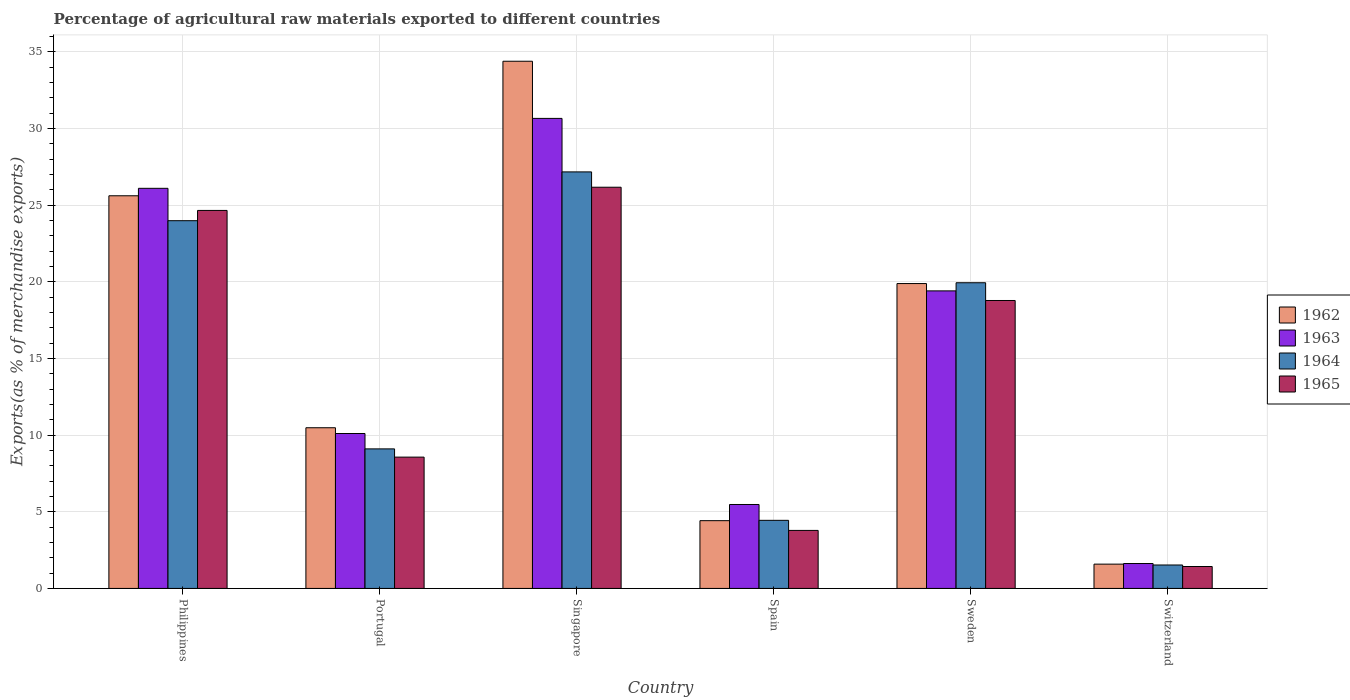Are the number of bars on each tick of the X-axis equal?
Your response must be concise. Yes. How many bars are there on the 6th tick from the left?
Your answer should be compact. 4. How many bars are there on the 4th tick from the right?
Offer a terse response. 4. What is the percentage of exports to different countries in 1964 in Spain?
Provide a short and direct response. 4.44. Across all countries, what is the maximum percentage of exports to different countries in 1962?
Give a very brief answer. 34.38. Across all countries, what is the minimum percentage of exports to different countries in 1965?
Give a very brief answer. 1.43. In which country was the percentage of exports to different countries in 1962 maximum?
Provide a succinct answer. Singapore. In which country was the percentage of exports to different countries in 1965 minimum?
Provide a succinct answer. Switzerland. What is the total percentage of exports to different countries in 1963 in the graph?
Offer a very short reply. 93.34. What is the difference between the percentage of exports to different countries in 1965 in Philippines and that in Portugal?
Your answer should be compact. 16.08. What is the difference between the percentage of exports to different countries in 1965 in Singapore and the percentage of exports to different countries in 1963 in Philippines?
Keep it short and to the point. 0.07. What is the average percentage of exports to different countries in 1964 per country?
Offer a very short reply. 14.36. What is the difference between the percentage of exports to different countries of/in 1965 and percentage of exports to different countries of/in 1964 in Portugal?
Give a very brief answer. -0.54. In how many countries, is the percentage of exports to different countries in 1964 greater than 20 %?
Provide a succinct answer. 2. What is the ratio of the percentage of exports to different countries in 1963 in Philippines to that in Sweden?
Your answer should be very brief. 1.34. What is the difference between the highest and the second highest percentage of exports to different countries in 1962?
Your response must be concise. -8.77. What is the difference between the highest and the lowest percentage of exports to different countries in 1963?
Ensure brevity in your answer.  29.02. What does the 4th bar from the left in Sweden represents?
Your answer should be compact. 1965. What does the 2nd bar from the right in Singapore represents?
Your answer should be very brief. 1964. How many countries are there in the graph?
Your response must be concise. 6. What is the difference between two consecutive major ticks on the Y-axis?
Offer a very short reply. 5. Does the graph contain any zero values?
Your answer should be compact. No. Where does the legend appear in the graph?
Your response must be concise. Center right. How many legend labels are there?
Provide a succinct answer. 4. How are the legend labels stacked?
Offer a terse response. Vertical. What is the title of the graph?
Your answer should be compact. Percentage of agricultural raw materials exported to different countries. What is the label or title of the X-axis?
Your answer should be compact. Country. What is the label or title of the Y-axis?
Ensure brevity in your answer.  Exports(as % of merchandise exports). What is the Exports(as % of merchandise exports) of 1962 in Philippines?
Your answer should be compact. 25.6. What is the Exports(as % of merchandise exports) of 1963 in Philippines?
Provide a succinct answer. 26.09. What is the Exports(as % of merchandise exports) of 1964 in Philippines?
Ensure brevity in your answer.  23.98. What is the Exports(as % of merchandise exports) in 1965 in Philippines?
Give a very brief answer. 24.65. What is the Exports(as % of merchandise exports) of 1962 in Portugal?
Your answer should be compact. 10.48. What is the Exports(as % of merchandise exports) in 1963 in Portugal?
Give a very brief answer. 10.1. What is the Exports(as % of merchandise exports) in 1964 in Portugal?
Offer a very short reply. 9.1. What is the Exports(as % of merchandise exports) in 1965 in Portugal?
Ensure brevity in your answer.  8.56. What is the Exports(as % of merchandise exports) in 1962 in Singapore?
Your response must be concise. 34.38. What is the Exports(as % of merchandise exports) of 1963 in Singapore?
Ensure brevity in your answer.  30.65. What is the Exports(as % of merchandise exports) in 1964 in Singapore?
Make the answer very short. 27.16. What is the Exports(as % of merchandise exports) of 1965 in Singapore?
Your response must be concise. 26.16. What is the Exports(as % of merchandise exports) of 1962 in Spain?
Make the answer very short. 4.42. What is the Exports(as % of merchandise exports) in 1963 in Spain?
Make the answer very short. 5.47. What is the Exports(as % of merchandise exports) of 1964 in Spain?
Your answer should be very brief. 4.44. What is the Exports(as % of merchandise exports) of 1965 in Spain?
Your answer should be compact. 3.78. What is the Exports(as % of merchandise exports) in 1962 in Sweden?
Give a very brief answer. 19.88. What is the Exports(as % of merchandise exports) in 1963 in Sweden?
Ensure brevity in your answer.  19.4. What is the Exports(as % of merchandise exports) in 1964 in Sweden?
Your response must be concise. 19.93. What is the Exports(as % of merchandise exports) of 1965 in Sweden?
Ensure brevity in your answer.  18.78. What is the Exports(as % of merchandise exports) of 1962 in Switzerland?
Offer a terse response. 1.58. What is the Exports(as % of merchandise exports) in 1963 in Switzerland?
Your answer should be very brief. 1.62. What is the Exports(as % of merchandise exports) in 1964 in Switzerland?
Ensure brevity in your answer.  1.53. What is the Exports(as % of merchandise exports) of 1965 in Switzerland?
Make the answer very short. 1.43. Across all countries, what is the maximum Exports(as % of merchandise exports) in 1962?
Give a very brief answer. 34.38. Across all countries, what is the maximum Exports(as % of merchandise exports) of 1963?
Your answer should be compact. 30.65. Across all countries, what is the maximum Exports(as % of merchandise exports) in 1964?
Offer a very short reply. 27.16. Across all countries, what is the maximum Exports(as % of merchandise exports) of 1965?
Your response must be concise. 26.16. Across all countries, what is the minimum Exports(as % of merchandise exports) in 1962?
Keep it short and to the point. 1.58. Across all countries, what is the minimum Exports(as % of merchandise exports) of 1963?
Give a very brief answer. 1.62. Across all countries, what is the minimum Exports(as % of merchandise exports) in 1964?
Ensure brevity in your answer.  1.53. Across all countries, what is the minimum Exports(as % of merchandise exports) in 1965?
Make the answer very short. 1.43. What is the total Exports(as % of merchandise exports) in 1962 in the graph?
Keep it short and to the point. 96.34. What is the total Exports(as % of merchandise exports) of 1963 in the graph?
Keep it short and to the point. 93.34. What is the total Exports(as % of merchandise exports) of 1964 in the graph?
Your answer should be compact. 86.14. What is the total Exports(as % of merchandise exports) of 1965 in the graph?
Keep it short and to the point. 83.36. What is the difference between the Exports(as % of merchandise exports) in 1962 in Philippines and that in Portugal?
Provide a succinct answer. 15.13. What is the difference between the Exports(as % of merchandise exports) of 1963 in Philippines and that in Portugal?
Your answer should be very brief. 15.99. What is the difference between the Exports(as % of merchandise exports) of 1964 in Philippines and that in Portugal?
Provide a succinct answer. 14.88. What is the difference between the Exports(as % of merchandise exports) of 1965 in Philippines and that in Portugal?
Offer a very short reply. 16.08. What is the difference between the Exports(as % of merchandise exports) in 1962 in Philippines and that in Singapore?
Keep it short and to the point. -8.77. What is the difference between the Exports(as % of merchandise exports) in 1963 in Philippines and that in Singapore?
Your response must be concise. -4.56. What is the difference between the Exports(as % of merchandise exports) of 1964 in Philippines and that in Singapore?
Ensure brevity in your answer.  -3.18. What is the difference between the Exports(as % of merchandise exports) of 1965 in Philippines and that in Singapore?
Your answer should be compact. -1.51. What is the difference between the Exports(as % of merchandise exports) of 1962 in Philippines and that in Spain?
Provide a succinct answer. 21.19. What is the difference between the Exports(as % of merchandise exports) in 1963 in Philippines and that in Spain?
Ensure brevity in your answer.  20.62. What is the difference between the Exports(as % of merchandise exports) in 1964 in Philippines and that in Spain?
Keep it short and to the point. 19.54. What is the difference between the Exports(as % of merchandise exports) of 1965 in Philippines and that in Spain?
Provide a succinct answer. 20.86. What is the difference between the Exports(as % of merchandise exports) in 1962 in Philippines and that in Sweden?
Keep it short and to the point. 5.72. What is the difference between the Exports(as % of merchandise exports) of 1963 in Philippines and that in Sweden?
Make the answer very short. 6.69. What is the difference between the Exports(as % of merchandise exports) in 1964 in Philippines and that in Sweden?
Offer a terse response. 4.05. What is the difference between the Exports(as % of merchandise exports) in 1965 in Philippines and that in Sweden?
Keep it short and to the point. 5.87. What is the difference between the Exports(as % of merchandise exports) of 1962 in Philippines and that in Switzerland?
Ensure brevity in your answer.  24.02. What is the difference between the Exports(as % of merchandise exports) of 1963 in Philippines and that in Switzerland?
Ensure brevity in your answer.  24.47. What is the difference between the Exports(as % of merchandise exports) of 1964 in Philippines and that in Switzerland?
Your response must be concise. 22.45. What is the difference between the Exports(as % of merchandise exports) of 1965 in Philippines and that in Switzerland?
Offer a very short reply. 23.22. What is the difference between the Exports(as % of merchandise exports) of 1962 in Portugal and that in Singapore?
Make the answer very short. -23.9. What is the difference between the Exports(as % of merchandise exports) in 1963 in Portugal and that in Singapore?
Keep it short and to the point. -20.55. What is the difference between the Exports(as % of merchandise exports) in 1964 in Portugal and that in Singapore?
Make the answer very short. -18.06. What is the difference between the Exports(as % of merchandise exports) in 1965 in Portugal and that in Singapore?
Offer a very short reply. -17.6. What is the difference between the Exports(as % of merchandise exports) in 1962 in Portugal and that in Spain?
Give a very brief answer. 6.06. What is the difference between the Exports(as % of merchandise exports) of 1963 in Portugal and that in Spain?
Your answer should be compact. 4.63. What is the difference between the Exports(as % of merchandise exports) of 1964 in Portugal and that in Spain?
Offer a very short reply. 4.66. What is the difference between the Exports(as % of merchandise exports) in 1965 in Portugal and that in Spain?
Ensure brevity in your answer.  4.78. What is the difference between the Exports(as % of merchandise exports) in 1962 in Portugal and that in Sweden?
Your answer should be very brief. -9.4. What is the difference between the Exports(as % of merchandise exports) in 1963 in Portugal and that in Sweden?
Your answer should be compact. -9.3. What is the difference between the Exports(as % of merchandise exports) of 1964 in Portugal and that in Sweden?
Offer a terse response. -10.83. What is the difference between the Exports(as % of merchandise exports) of 1965 in Portugal and that in Sweden?
Give a very brief answer. -10.21. What is the difference between the Exports(as % of merchandise exports) in 1962 in Portugal and that in Switzerland?
Keep it short and to the point. 8.89. What is the difference between the Exports(as % of merchandise exports) in 1963 in Portugal and that in Switzerland?
Offer a very short reply. 8.48. What is the difference between the Exports(as % of merchandise exports) of 1964 in Portugal and that in Switzerland?
Provide a succinct answer. 7.57. What is the difference between the Exports(as % of merchandise exports) in 1965 in Portugal and that in Switzerland?
Ensure brevity in your answer.  7.13. What is the difference between the Exports(as % of merchandise exports) of 1962 in Singapore and that in Spain?
Keep it short and to the point. 29.96. What is the difference between the Exports(as % of merchandise exports) of 1963 in Singapore and that in Spain?
Your answer should be very brief. 25.18. What is the difference between the Exports(as % of merchandise exports) in 1964 in Singapore and that in Spain?
Keep it short and to the point. 22.72. What is the difference between the Exports(as % of merchandise exports) in 1965 in Singapore and that in Spain?
Give a very brief answer. 22.38. What is the difference between the Exports(as % of merchandise exports) in 1962 in Singapore and that in Sweden?
Your response must be concise. 14.5. What is the difference between the Exports(as % of merchandise exports) in 1963 in Singapore and that in Sweden?
Provide a succinct answer. 11.25. What is the difference between the Exports(as % of merchandise exports) of 1964 in Singapore and that in Sweden?
Your answer should be very brief. 7.23. What is the difference between the Exports(as % of merchandise exports) of 1965 in Singapore and that in Sweden?
Your answer should be compact. 7.39. What is the difference between the Exports(as % of merchandise exports) in 1962 in Singapore and that in Switzerland?
Offer a very short reply. 32.79. What is the difference between the Exports(as % of merchandise exports) of 1963 in Singapore and that in Switzerland?
Your response must be concise. 29.02. What is the difference between the Exports(as % of merchandise exports) in 1964 in Singapore and that in Switzerland?
Your answer should be compact. 25.63. What is the difference between the Exports(as % of merchandise exports) of 1965 in Singapore and that in Switzerland?
Provide a succinct answer. 24.73. What is the difference between the Exports(as % of merchandise exports) in 1962 in Spain and that in Sweden?
Offer a terse response. -15.46. What is the difference between the Exports(as % of merchandise exports) in 1963 in Spain and that in Sweden?
Your answer should be very brief. -13.93. What is the difference between the Exports(as % of merchandise exports) of 1964 in Spain and that in Sweden?
Your answer should be compact. -15.49. What is the difference between the Exports(as % of merchandise exports) in 1965 in Spain and that in Sweden?
Offer a very short reply. -14.99. What is the difference between the Exports(as % of merchandise exports) in 1962 in Spain and that in Switzerland?
Give a very brief answer. 2.83. What is the difference between the Exports(as % of merchandise exports) of 1963 in Spain and that in Switzerland?
Ensure brevity in your answer.  3.85. What is the difference between the Exports(as % of merchandise exports) in 1964 in Spain and that in Switzerland?
Your answer should be very brief. 2.91. What is the difference between the Exports(as % of merchandise exports) of 1965 in Spain and that in Switzerland?
Provide a short and direct response. 2.35. What is the difference between the Exports(as % of merchandise exports) of 1962 in Sweden and that in Switzerland?
Your answer should be very brief. 18.3. What is the difference between the Exports(as % of merchandise exports) in 1963 in Sweden and that in Switzerland?
Make the answer very short. 17.78. What is the difference between the Exports(as % of merchandise exports) of 1964 in Sweden and that in Switzerland?
Your answer should be compact. 18.4. What is the difference between the Exports(as % of merchandise exports) of 1965 in Sweden and that in Switzerland?
Your answer should be compact. 17.35. What is the difference between the Exports(as % of merchandise exports) in 1962 in Philippines and the Exports(as % of merchandise exports) in 1963 in Portugal?
Your answer should be very brief. 15.5. What is the difference between the Exports(as % of merchandise exports) of 1962 in Philippines and the Exports(as % of merchandise exports) of 1964 in Portugal?
Make the answer very short. 16.5. What is the difference between the Exports(as % of merchandise exports) in 1962 in Philippines and the Exports(as % of merchandise exports) in 1965 in Portugal?
Provide a short and direct response. 17.04. What is the difference between the Exports(as % of merchandise exports) of 1963 in Philippines and the Exports(as % of merchandise exports) of 1964 in Portugal?
Your response must be concise. 16.99. What is the difference between the Exports(as % of merchandise exports) of 1963 in Philippines and the Exports(as % of merchandise exports) of 1965 in Portugal?
Provide a succinct answer. 17.53. What is the difference between the Exports(as % of merchandise exports) of 1964 in Philippines and the Exports(as % of merchandise exports) of 1965 in Portugal?
Your answer should be very brief. 15.42. What is the difference between the Exports(as % of merchandise exports) in 1962 in Philippines and the Exports(as % of merchandise exports) in 1963 in Singapore?
Your answer should be compact. -5.04. What is the difference between the Exports(as % of merchandise exports) in 1962 in Philippines and the Exports(as % of merchandise exports) in 1964 in Singapore?
Provide a succinct answer. -1.56. What is the difference between the Exports(as % of merchandise exports) in 1962 in Philippines and the Exports(as % of merchandise exports) in 1965 in Singapore?
Your answer should be very brief. -0.56. What is the difference between the Exports(as % of merchandise exports) in 1963 in Philippines and the Exports(as % of merchandise exports) in 1964 in Singapore?
Ensure brevity in your answer.  -1.07. What is the difference between the Exports(as % of merchandise exports) in 1963 in Philippines and the Exports(as % of merchandise exports) in 1965 in Singapore?
Offer a terse response. -0.07. What is the difference between the Exports(as % of merchandise exports) in 1964 in Philippines and the Exports(as % of merchandise exports) in 1965 in Singapore?
Your answer should be compact. -2.18. What is the difference between the Exports(as % of merchandise exports) in 1962 in Philippines and the Exports(as % of merchandise exports) in 1963 in Spain?
Provide a succinct answer. 20.13. What is the difference between the Exports(as % of merchandise exports) of 1962 in Philippines and the Exports(as % of merchandise exports) of 1964 in Spain?
Provide a short and direct response. 21.16. What is the difference between the Exports(as % of merchandise exports) of 1962 in Philippines and the Exports(as % of merchandise exports) of 1965 in Spain?
Keep it short and to the point. 21.82. What is the difference between the Exports(as % of merchandise exports) in 1963 in Philippines and the Exports(as % of merchandise exports) in 1964 in Spain?
Your response must be concise. 21.65. What is the difference between the Exports(as % of merchandise exports) of 1963 in Philippines and the Exports(as % of merchandise exports) of 1965 in Spain?
Offer a very short reply. 22.31. What is the difference between the Exports(as % of merchandise exports) of 1964 in Philippines and the Exports(as % of merchandise exports) of 1965 in Spain?
Provide a succinct answer. 20.2. What is the difference between the Exports(as % of merchandise exports) of 1962 in Philippines and the Exports(as % of merchandise exports) of 1963 in Sweden?
Offer a very short reply. 6.2. What is the difference between the Exports(as % of merchandise exports) in 1962 in Philippines and the Exports(as % of merchandise exports) in 1964 in Sweden?
Make the answer very short. 5.67. What is the difference between the Exports(as % of merchandise exports) of 1962 in Philippines and the Exports(as % of merchandise exports) of 1965 in Sweden?
Your answer should be compact. 6.83. What is the difference between the Exports(as % of merchandise exports) in 1963 in Philippines and the Exports(as % of merchandise exports) in 1964 in Sweden?
Offer a terse response. 6.16. What is the difference between the Exports(as % of merchandise exports) in 1963 in Philippines and the Exports(as % of merchandise exports) in 1965 in Sweden?
Your answer should be very brief. 7.31. What is the difference between the Exports(as % of merchandise exports) of 1964 in Philippines and the Exports(as % of merchandise exports) of 1965 in Sweden?
Your answer should be very brief. 5.2. What is the difference between the Exports(as % of merchandise exports) in 1962 in Philippines and the Exports(as % of merchandise exports) in 1963 in Switzerland?
Provide a succinct answer. 23.98. What is the difference between the Exports(as % of merchandise exports) in 1962 in Philippines and the Exports(as % of merchandise exports) in 1964 in Switzerland?
Your answer should be very brief. 24.08. What is the difference between the Exports(as % of merchandise exports) in 1962 in Philippines and the Exports(as % of merchandise exports) in 1965 in Switzerland?
Keep it short and to the point. 24.17. What is the difference between the Exports(as % of merchandise exports) in 1963 in Philippines and the Exports(as % of merchandise exports) in 1964 in Switzerland?
Give a very brief answer. 24.56. What is the difference between the Exports(as % of merchandise exports) of 1963 in Philippines and the Exports(as % of merchandise exports) of 1965 in Switzerland?
Offer a very short reply. 24.66. What is the difference between the Exports(as % of merchandise exports) of 1964 in Philippines and the Exports(as % of merchandise exports) of 1965 in Switzerland?
Provide a short and direct response. 22.55. What is the difference between the Exports(as % of merchandise exports) of 1962 in Portugal and the Exports(as % of merchandise exports) of 1963 in Singapore?
Your answer should be compact. -20.17. What is the difference between the Exports(as % of merchandise exports) in 1962 in Portugal and the Exports(as % of merchandise exports) in 1964 in Singapore?
Ensure brevity in your answer.  -16.68. What is the difference between the Exports(as % of merchandise exports) in 1962 in Portugal and the Exports(as % of merchandise exports) in 1965 in Singapore?
Give a very brief answer. -15.68. What is the difference between the Exports(as % of merchandise exports) in 1963 in Portugal and the Exports(as % of merchandise exports) in 1964 in Singapore?
Provide a short and direct response. -17.06. What is the difference between the Exports(as % of merchandise exports) of 1963 in Portugal and the Exports(as % of merchandise exports) of 1965 in Singapore?
Your response must be concise. -16.06. What is the difference between the Exports(as % of merchandise exports) of 1964 in Portugal and the Exports(as % of merchandise exports) of 1965 in Singapore?
Make the answer very short. -17.06. What is the difference between the Exports(as % of merchandise exports) of 1962 in Portugal and the Exports(as % of merchandise exports) of 1963 in Spain?
Provide a short and direct response. 5. What is the difference between the Exports(as % of merchandise exports) in 1962 in Portugal and the Exports(as % of merchandise exports) in 1964 in Spain?
Your answer should be very brief. 6.04. What is the difference between the Exports(as % of merchandise exports) of 1962 in Portugal and the Exports(as % of merchandise exports) of 1965 in Spain?
Ensure brevity in your answer.  6.7. What is the difference between the Exports(as % of merchandise exports) in 1963 in Portugal and the Exports(as % of merchandise exports) in 1964 in Spain?
Make the answer very short. 5.66. What is the difference between the Exports(as % of merchandise exports) of 1963 in Portugal and the Exports(as % of merchandise exports) of 1965 in Spain?
Offer a very short reply. 6.32. What is the difference between the Exports(as % of merchandise exports) of 1964 in Portugal and the Exports(as % of merchandise exports) of 1965 in Spain?
Offer a very short reply. 5.32. What is the difference between the Exports(as % of merchandise exports) of 1962 in Portugal and the Exports(as % of merchandise exports) of 1963 in Sweden?
Your answer should be compact. -8.92. What is the difference between the Exports(as % of merchandise exports) of 1962 in Portugal and the Exports(as % of merchandise exports) of 1964 in Sweden?
Your response must be concise. -9.45. What is the difference between the Exports(as % of merchandise exports) of 1962 in Portugal and the Exports(as % of merchandise exports) of 1965 in Sweden?
Give a very brief answer. -8.3. What is the difference between the Exports(as % of merchandise exports) in 1963 in Portugal and the Exports(as % of merchandise exports) in 1964 in Sweden?
Offer a very short reply. -9.83. What is the difference between the Exports(as % of merchandise exports) of 1963 in Portugal and the Exports(as % of merchandise exports) of 1965 in Sweden?
Provide a succinct answer. -8.67. What is the difference between the Exports(as % of merchandise exports) of 1964 in Portugal and the Exports(as % of merchandise exports) of 1965 in Sweden?
Give a very brief answer. -9.68. What is the difference between the Exports(as % of merchandise exports) in 1962 in Portugal and the Exports(as % of merchandise exports) in 1963 in Switzerland?
Your answer should be compact. 8.85. What is the difference between the Exports(as % of merchandise exports) of 1962 in Portugal and the Exports(as % of merchandise exports) of 1964 in Switzerland?
Keep it short and to the point. 8.95. What is the difference between the Exports(as % of merchandise exports) of 1962 in Portugal and the Exports(as % of merchandise exports) of 1965 in Switzerland?
Ensure brevity in your answer.  9.05. What is the difference between the Exports(as % of merchandise exports) of 1963 in Portugal and the Exports(as % of merchandise exports) of 1964 in Switzerland?
Ensure brevity in your answer.  8.57. What is the difference between the Exports(as % of merchandise exports) in 1963 in Portugal and the Exports(as % of merchandise exports) in 1965 in Switzerland?
Keep it short and to the point. 8.67. What is the difference between the Exports(as % of merchandise exports) in 1964 in Portugal and the Exports(as % of merchandise exports) in 1965 in Switzerland?
Your answer should be compact. 7.67. What is the difference between the Exports(as % of merchandise exports) of 1962 in Singapore and the Exports(as % of merchandise exports) of 1963 in Spain?
Offer a terse response. 28.9. What is the difference between the Exports(as % of merchandise exports) of 1962 in Singapore and the Exports(as % of merchandise exports) of 1964 in Spain?
Your response must be concise. 29.94. What is the difference between the Exports(as % of merchandise exports) in 1962 in Singapore and the Exports(as % of merchandise exports) in 1965 in Spain?
Give a very brief answer. 30.59. What is the difference between the Exports(as % of merchandise exports) in 1963 in Singapore and the Exports(as % of merchandise exports) in 1964 in Spain?
Provide a short and direct response. 26.21. What is the difference between the Exports(as % of merchandise exports) of 1963 in Singapore and the Exports(as % of merchandise exports) of 1965 in Spain?
Keep it short and to the point. 26.87. What is the difference between the Exports(as % of merchandise exports) of 1964 in Singapore and the Exports(as % of merchandise exports) of 1965 in Spain?
Give a very brief answer. 23.38. What is the difference between the Exports(as % of merchandise exports) in 1962 in Singapore and the Exports(as % of merchandise exports) in 1963 in Sweden?
Provide a succinct answer. 14.97. What is the difference between the Exports(as % of merchandise exports) in 1962 in Singapore and the Exports(as % of merchandise exports) in 1964 in Sweden?
Your answer should be very brief. 14.44. What is the difference between the Exports(as % of merchandise exports) in 1962 in Singapore and the Exports(as % of merchandise exports) in 1965 in Sweden?
Ensure brevity in your answer.  15.6. What is the difference between the Exports(as % of merchandise exports) of 1963 in Singapore and the Exports(as % of merchandise exports) of 1964 in Sweden?
Your response must be concise. 10.72. What is the difference between the Exports(as % of merchandise exports) of 1963 in Singapore and the Exports(as % of merchandise exports) of 1965 in Sweden?
Keep it short and to the point. 11.87. What is the difference between the Exports(as % of merchandise exports) in 1964 in Singapore and the Exports(as % of merchandise exports) in 1965 in Sweden?
Offer a terse response. 8.39. What is the difference between the Exports(as % of merchandise exports) in 1962 in Singapore and the Exports(as % of merchandise exports) in 1963 in Switzerland?
Ensure brevity in your answer.  32.75. What is the difference between the Exports(as % of merchandise exports) in 1962 in Singapore and the Exports(as % of merchandise exports) in 1964 in Switzerland?
Give a very brief answer. 32.85. What is the difference between the Exports(as % of merchandise exports) in 1962 in Singapore and the Exports(as % of merchandise exports) in 1965 in Switzerland?
Offer a terse response. 32.95. What is the difference between the Exports(as % of merchandise exports) in 1963 in Singapore and the Exports(as % of merchandise exports) in 1964 in Switzerland?
Keep it short and to the point. 29.12. What is the difference between the Exports(as % of merchandise exports) in 1963 in Singapore and the Exports(as % of merchandise exports) in 1965 in Switzerland?
Provide a short and direct response. 29.22. What is the difference between the Exports(as % of merchandise exports) of 1964 in Singapore and the Exports(as % of merchandise exports) of 1965 in Switzerland?
Your answer should be very brief. 25.73. What is the difference between the Exports(as % of merchandise exports) of 1962 in Spain and the Exports(as % of merchandise exports) of 1963 in Sweden?
Your response must be concise. -14.98. What is the difference between the Exports(as % of merchandise exports) in 1962 in Spain and the Exports(as % of merchandise exports) in 1964 in Sweden?
Offer a terse response. -15.51. What is the difference between the Exports(as % of merchandise exports) in 1962 in Spain and the Exports(as % of merchandise exports) in 1965 in Sweden?
Your response must be concise. -14.36. What is the difference between the Exports(as % of merchandise exports) of 1963 in Spain and the Exports(as % of merchandise exports) of 1964 in Sweden?
Provide a short and direct response. -14.46. What is the difference between the Exports(as % of merchandise exports) of 1963 in Spain and the Exports(as % of merchandise exports) of 1965 in Sweden?
Provide a succinct answer. -13.3. What is the difference between the Exports(as % of merchandise exports) in 1964 in Spain and the Exports(as % of merchandise exports) in 1965 in Sweden?
Make the answer very short. -14.33. What is the difference between the Exports(as % of merchandise exports) in 1962 in Spain and the Exports(as % of merchandise exports) in 1963 in Switzerland?
Your answer should be compact. 2.79. What is the difference between the Exports(as % of merchandise exports) in 1962 in Spain and the Exports(as % of merchandise exports) in 1964 in Switzerland?
Your answer should be very brief. 2.89. What is the difference between the Exports(as % of merchandise exports) in 1962 in Spain and the Exports(as % of merchandise exports) in 1965 in Switzerland?
Your answer should be compact. 2.99. What is the difference between the Exports(as % of merchandise exports) in 1963 in Spain and the Exports(as % of merchandise exports) in 1964 in Switzerland?
Your answer should be very brief. 3.94. What is the difference between the Exports(as % of merchandise exports) of 1963 in Spain and the Exports(as % of merchandise exports) of 1965 in Switzerland?
Your response must be concise. 4.04. What is the difference between the Exports(as % of merchandise exports) of 1964 in Spain and the Exports(as % of merchandise exports) of 1965 in Switzerland?
Your response must be concise. 3.01. What is the difference between the Exports(as % of merchandise exports) in 1962 in Sweden and the Exports(as % of merchandise exports) in 1963 in Switzerland?
Offer a very short reply. 18.26. What is the difference between the Exports(as % of merchandise exports) in 1962 in Sweden and the Exports(as % of merchandise exports) in 1964 in Switzerland?
Your response must be concise. 18.35. What is the difference between the Exports(as % of merchandise exports) in 1962 in Sweden and the Exports(as % of merchandise exports) in 1965 in Switzerland?
Your answer should be very brief. 18.45. What is the difference between the Exports(as % of merchandise exports) in 1963 in Sweden and the Exports(as % of merchandise exports) in 1964 in Switzerland?
Offer a very short reply. 17.87. What is the difference between the Exports(as % of merchandise exports) of 1963 in Sweden and the Exports(as % of merchandise exports) of 1965 in Switzerland?
Provide a short and direct response. 17.97. What is the difference between the Exports(as % of merchandise exports) in 1964 in Sweden and the Exports(as % of merchandise exports) in 1965 in Switzerland?
Provide a short and direct response. 18.5. What is the average Exports(as % of merchandise exports) of 1962 per country?
Your answer should be compact. 16.06. What is the average Exports(as % of merchandise exports) of 1963 per country?
Provide a succinct answer. 15.56. What is the average Exports(as % of merchandise exports) of 1964 per country?
Your response must be concise. 14.36. What is the average Exports(as % of merchandise exports) in 1965 per country?
Provide a short and direct response. 13.89. What is the difference between the Exports(as % of merchandise exports) in 1962 and Exports(as % of merchandise exports) in 1963 in Philippines?
Provide a succinct answer. -0.49. What is the difference between the Exports(as % of merchandise exports) of 1962 and Exports(as % of merchandise exports) of 1964 in Philippines?
Your response must be concise. 1.63. What is the difference between the Exports(as % of merchandise exports) in 1962 and Exports(as % of merchandise exports) in 1965 in Philippines?
Give a very brief answer. 0.96. What is the difference between the Exports(as % of merchandise exports) in 1963 and Exports(as % of merchandise exports) in 1964 in Philippines?
Your response must be concise. 2.11. What is the difference between the Exports(as % of merchandise exports) in 1963 and Exports(as % of merchandise exports) in 1965 in Philippines?
Provide a short and direct response. 1.44. What is the difference between the Exports(as % of merchandise exports) in 1964 and Exports(as % of merchandise exports) in 1965 in Philippines?
Give a very brief answer. -0.67. What is the difference between the Exports(as % of merchandise exports) of 1962 and Exports(as % of merchandise exports) of 1963 in Portugal?
Provide a short and direct response. 0.38. What is the difference between the Exports(as % of merchandise exports) in 1962 and Exports(as % of merchandise exports) in 1964 in Portugal?
Your answer should be compact. 1.38. What is the difference between the Exports(as % of merchandise exports) in 1962 and Exports(as % of merchandise exports) in 1965 in Portugal?
Your response must be concise. 1.92. What is the difference between the Exports(as % of merchandise exports) of 1963 and Exports(as % of merchandise exports) of 1964 in Portugal?
Offer a very short reply. 1. What is the difference between the Exports(as % of merchandise exports) of 1963 and Exports(as % of merchandise exports) of 1965 in Portugal?
Offer a very short reply. 1.54. What is the difference between the Exports(as % of merchandise exports) of 1964 and Exports(as % of merchandise exports) of 1965 in Portugal?
Provide a succinct answer. 0.54. What is the difference between the Exports(as % of merchandise exports) in 1962 and Exports(as % of merchandise exports) in 1963 in Singapore?
Your answer should be very brief. 3.73. What is the difference between the Exports(as % of merchandise exports) of 1962 and Exports(as % of merchandise exports) of 1964 in Singapore?
Provide a succinct answer. 7.22. What is the difference between the Exports(as % of merchandise exports) in 1962 and Exports(as % of merchandise exports) in 1965 in Singapore?
Provide a short and direct response. 8.22. What is the difference between the Exports(as % of merchandise exports) in 1963 and Exports(as % of merchandise exports) in 1964 in Singapore?
Your answer should be very brief. 3.49. What is the difference between the Exports(as % of merchandise exports) in 1963 and Exports(as % of merchandise exports) in 1965 in Singapore?
Make the answer very short. 4.49. What is the difference between the Exports(as % of merchandise exports) in 1962 and Exports(as % of merchandise exports) in 1963 in Spain?
Your answer should be very brief. -1.06. What is the difference between the Exports(as % of merchandise exports) of 1962 and Exports(as % of merchandise exports) of 1964 in Spain?
Make the answer very short. -0.02. What is the difference between the Exports(as % of merchandise exports) of 1962 and Exports(as % of merchandise exports) of 1965 in Spain?
Your answer should be very brief. 0.64. What is the difference between the Exports(as % of merchandise exports) of 1963 and Exports(as % of merchandise exports) of 1964 in Spain?
Your answer should be very brief. 1.03. What is the difference between the Exports(as % of merchandise exports) of 1963 and Exports(as % of merchandise exports) of 1965 in Spain?
Your answer should be compact. 1.69. What is the difference between the Exports(as % of merchandise exports) in 1964 and Exports(as % of merchandise exports) in 1965 in Spain?
Your answer should be very brief. 0.66. What is the difference between the Exports(as % of merchandise exports) in 1962 and Exports(as % of merchandise exports) in 1963 in Sweden?
Make the answer very short. 0.48. What is the difference between the Exports(as % of merchandise exports) of 1962 and Exports(as % of merchandise exports) of 1964 in Sweden?
Provide a succinct answer. -0.05. What is the difference between the Exports(as % of merchandise exports) of 1962 and Exports(as % of merchandise exports) of 1965 in Sweden?
Your response must be concise. 1.1. What is the difference between the Exports(as % of merchandise exports) of 1963 and Exports(as % of merchandise exports) of 1964 in Sweden?
Ensure brevity in your answer.  -0.53. What is the difference between the Exports(as % of merchandise exports) in 1963 and Exports(as % of merchandise exports) in 1965 in Sweden?
Give a very brief answer. 0.63. What is the difference between the Exports(as % of merchandise exports) in 1964 and Exports(as % of merchandise exports) in 1965 in Sweden?
Ensure brevity in your answer.  1.16. What is the difference between the Exports(as % of merchandise exports) of 1962 and Exports(as % of merchandise exports) of 1963 in Switzerland?
Ensure brevity in your answer.  -0.04. What is the difference between the Exports(as % of merchandise exports) of 1962 and Exports(as % of merchandise exports) of 1964 in Switzerland?
Provide a short and direct response. 0.06. What is the difference between the Exports(as % of merchandise exports) in 1962 and Exports(as % of merchandise exports) in 1965 in Switzerland?
Your answer should be very brief. 0.15. What is the difference between the Exports(as % of merchandise exports) of 1963 and Exports(as % of merchandise exports) of 1964 in Switzerland?
Your answer should be very brief. 0.1. What is the difference between the Exports(as % of merchandise exports) in 1963 and Exports(as % of merchandise exports) in 1965 in Switzerland?
Your answer should be very brief. 0.19. What is the difference between the Exports(as % of merchandise exports) in 1964 and Exports(as % of merchandise exports) in 1965 in Switzerland?
Make the answer very short. 0.1. What is the ratio of the Exports(as % of merchandise exports) of 1962 in Philippines to that in Portugal?
Provide a short and direct response. 2.44. What is the ratio of the Exports(as % of merchandise exports) in 1963 in Philippines to that in Portugal?
Ensure brevity in your answer.  2.58. What is the ratio of the Exports(as % of merchandise exports) of 1964 in Philippines to that in Portugal?
Offer a very short reply. 2.64. What is the ratio of the Exports(as % of merchandise exports) of 1965 in Philippines to that in Portugal?
Provide a short and direct response. 2.88. What is the ratio of the Exports(as % of merchandise exports) in 1962 in Philippines to that in Singapore?
Your response must be concise. 0.74. What is the ratio of the Exports(as % of merchandise exports) in 1963 in Philippines to that in Singapore?
Give a very brief answer. 0.85. What is the ratio of the Exports(as % of merchandise exports) of 1964 in Philippines to that in Singapore?
Give a very brief answer. 0.88. What is the ratio of the Exports(as % of merchandise exports) in 1965 in Philippines to that in Singapore?
Offer a very short reply. 0.94. What is the ratio of the Exports(as % of merchandise exports) of 1962 in Philippines to that in Spain?
Provide a succinct answer. 5.79. What is the ratio of the Exports(as % of merchandise exports) of 1963 in Philippines to that in Spain?
Provide a succinct answer. 4.77. What is the ratio of the Exports(as % of merchandise exports) of 1964 in Philippines to that in Spain?
Give a very brief answer. 5.4. What is the ratio of the Exports(as % of merchandise exports) in 1965 in Philippines to that in Spain?
Ensure brevity in your answer.  6.52. What is the ratio of the Exports(as % of merchandise exports) in 1962 in Philippines to that in Sweden?
Your answer should be very brief. 1.29. What is the ratio of the Exports(as % of merchandise exports) of 1963 in Philippines to that in Sweden?
Your response must be concise. 1.34. What is the ratio of the Exports(as % of merchandise exports) in 1964 in Philippines to that in Sweden?
Offer a terse response. 1.2. What is the ratio of the Exports(as % of merchandise exports) in 1965 in Philippines to that in Sweden?
Keep it short and to the point. 1.31. What is the ratio of the Exports(as % of merchandise exports) in 1962 in Philippines to that in Switzerland?
Offer a terse response. 16.16. What is the ratio of the Exports(as % of merchandise exports) of 1963 in Philippines to that in Switzerland?
Your answer should be very brief. 16.06. What is the ratio of the Exports(as % of merchandise exports) of 1964 in Philippines to that in Switzerland?
Ensure brevity in your answer.  15.68. What is the ratio of the Exports(as % of merchandise exports) of 1965 in Philippines to that in Switzerland?
Offer a terse response. 17.24. What is the ratio of the Exports(as % of merchandise exports) of 1962 in Portugal to that in Singapore?
Your answer should be very brief. 0.3. What is the ratio of the Exports(as % of merchandise exports) in 1963 in Portugal to that in Singapore?
Ensure brevity in your answer.  0.33. What is the ratio of the Exports(as % of merchandise exports) in 1964 in Portugal to that in Singapore?
Provide a succinct answer. 0.34. What is the ratio of the Exports(as % of merchandise exports) of 1965 in Portugal to that in Singapore?
Your answer should be very brief. 0.33. What is the ratio of the Exports(as % of merchandise exports) of 1962 in Portugal to that in Spain?
Offer a very short reply. 2.37. What is the ratio of the Exports(as % of merchandise exports) in 1963 in Portugal to that in Spain?
Your answer should be very brief. 1.85. What is the ratio of the Exports(as % of merchandise exports) in 1964 in Portugal to that in Spain?
Ensure brevity in your answer.  2.05. What is the ratio of the Exports(as % of merchandise exports) of 1965 in Portugal to that in Spain?
Your answer should be very brief. 2.26. What is the ratio of the Exports(as % of merchandise exports) in 1962 in Portugal to that in Sweden?
Offer a very short reply. 0.53. What is the ratio of the Exports(as % of merchandise exports) in 1963 in Portugal to that in Sweden?
Ensure brevity in your answer.  0.52. What is the ratio of the Exports(as % of merchandise exports) in 1964 in Portugal to that in Sweden?
Your answer should be very brief. 0.46. What is the ratio of the Exports(as % of merchandise exports) in 1965 in Portugal to that in Sweden?
Your response must be concise. 0.46. What is the ratio of the Exports(as % of merchandise exports) of 1962 in Portugal to that in Switzerland?
Offer a very short reply. 6.61. What is the ratio of the Exports(as % of merchandise exports) of 1963 in Portugal to that in Switzerland?
Provide a succinct answer. 6.22. What is the ratio of the Exports(as % of merchandise exports) of 1964 in Portugal to that in Switzerland?
Provide a succinct answer. 5.95. What is the ratio of the Exports(as % of merchandise exports) of 1965 in Portugal to that in Switzerland?
Offer a very short reply. 5.99. What is the ratio of the Exports(as % of merchandise exports) in 1962 in Singapore to that in Spain?
Your answer should be compact. 7.78. What is the ratio of the Exports(as % of merchandise exports) in 1963 in Singapore to that in Spain?
Provide a succinct answer. 5.6. What is the ratio of the Exports(as % of merchandise exports) of 1964 in Singapore to that in Spain?
Offer a very short reply. 6.12. What is the ratio of the Exports(as % of merchandise exports) in 1965 in Singapore to that in Spain?
Make the answer very short. 6.92. What is the ratio of the Exports(as % of merchandise exports) in 1962 in Singapore to that in Sweden?
Provide a succinct answer. 1.73. What is the ratio of the Exports(as % of merchandise exports) of 1963 in Singapore to that in Sweden?
Keep it short and to the point. 1.58. What is the ratio of the Exports(as % of merchandise exports) in 1964 in Singapore to that in Sweden?
Provide a short and direct response. 1.36. What is the ratio of the Exports(as % of merchandise exports) in 1965 in Singapore to that in Sweden?
Ensure brevity in your answer.  1.39. What is the ratio of the Exports(as % of merchandise exports) of 1962 in Singapore to that in Switzerland?
Your answer should be very brief. 21.7. What is the ratio of the Exports(as % of merchandise exports) of 1963 in Singapore to that in Switzerland?
Provide a short and direct response. 18.87. What is the ratio of the Exports(as % of merchandise exports) in 1964 in Singapore to that in Switzerland?
Provide a short and direct response. 17.76. What is the ratio of the Exports(as % of merchandise exports) in 1965 in Singapore to that in Switzerland?
Your answer should be compact. 18.29. What is the ratio of the Exports(as % of merchandise exports) in 1962 in Spain to that in Sweden?
Make the answer very short. 0.22. What is the ratio of the Exports(as % of merchandise exports) in 1963 in Spain to that in Sweden?
Keep it short and to the point. 0.28. What is the ratio of the Exports(as % of merchandise exports) in 1964 in Spain to that in Sweden?
Your answer should be very brief. 0.22. What is the ratio of the Exports(as % of merchandise exports) of 1965 in Spain to that in Sweden?
Give a very brief answer. 0.2. What is the ratio of the Exports(as % of merchandise exports) in 1962 in Spain to that in Switzerland?
Your answer should be very brief. 2.79. What is the ratio of the Exports(as % of merchandise exports) in 1963 in Spain to that in Switzerland?
Offer a very short reply. 3.37. What is the ratio of the Exports(as % of merchandise exports) in 1964 in Spain to that in Switzerland?
Provide a succinct answer. 2.9. What is the ratio of the Exports(as % of merchandise exports) in 1965 in Spain to that in Switzerland?
Offer a very short reply. 2.65. What is the ratio of the Exports(as % of merchandise exports) in 1962 in Sweden to that in Switzerland?
Give a very brief answer. 12.55. What is the ratio of the Exports(as % of merchandise exports) in 1963 in Sweden to that in Switzerland?
Provide a succinct answer. 11.95. What is the ratio of the Exports(as % of merchandise exports) of 1964 in Sweden to that in Switzerland?
Offer a very short reply. 13.04. What is the ratio of the Exports(as % of merchandise exports) in 1965 in Sweden to that in Switzerland?
Make the answer very short. 13.13. What is the difference between the highest and the second highest Exports(as % of merchandise exports) in 1962?
Keep it short and to the point. 8.77. What is the difference between the highest and the second highest Exports(as % of merchandise exports) in 1963?
Your response must be concise. 4.56. What is the difference between the highest and the second highest Exports(as % of merchandise exports) of 1964?
Provide a short and direct response. 3.18. What is the difference between the highest and the second highest Exports(as % of merchandise exports) of 1965?
Your answer should be compact. 1.51. What is the difference between the highest and the lowest Exports(as % of merchandise exports) in 1962?
Ensure brevity in your answer.  32.79. What is the difference between the highest and the lowest Exports(as % of merchandise exports) in 1963?
Provide a short and direct response. 29.02. What is the difference between the highest and the lowest Exports(as % of merchandise exports) of 1964?
Make the answer very short. 25.63. What is the difference between the highest and the lowest Exports(as % of merchandise exports) of 1965?
Make the answer very short. 24.73. 